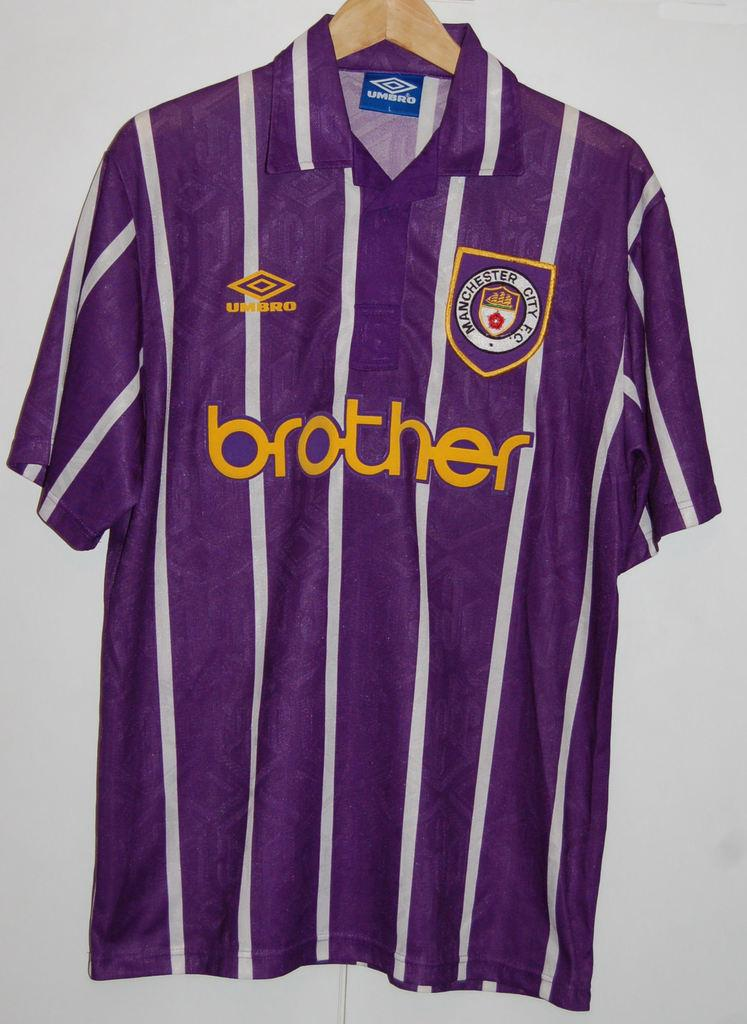<image>
Write a terse but informative summary of the picture. a white and purple soccer shirt that says brother on the center. 